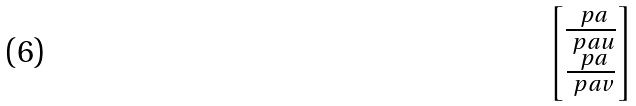Convert formula to latex. <formula><loc_0><loc_0><loc_500><loc_500>\begin{bmatrix} \frac { \ p a } { \ p a u } \\ \frac { \ p a } { \ p a v } \end{bmatrix}</formula> 